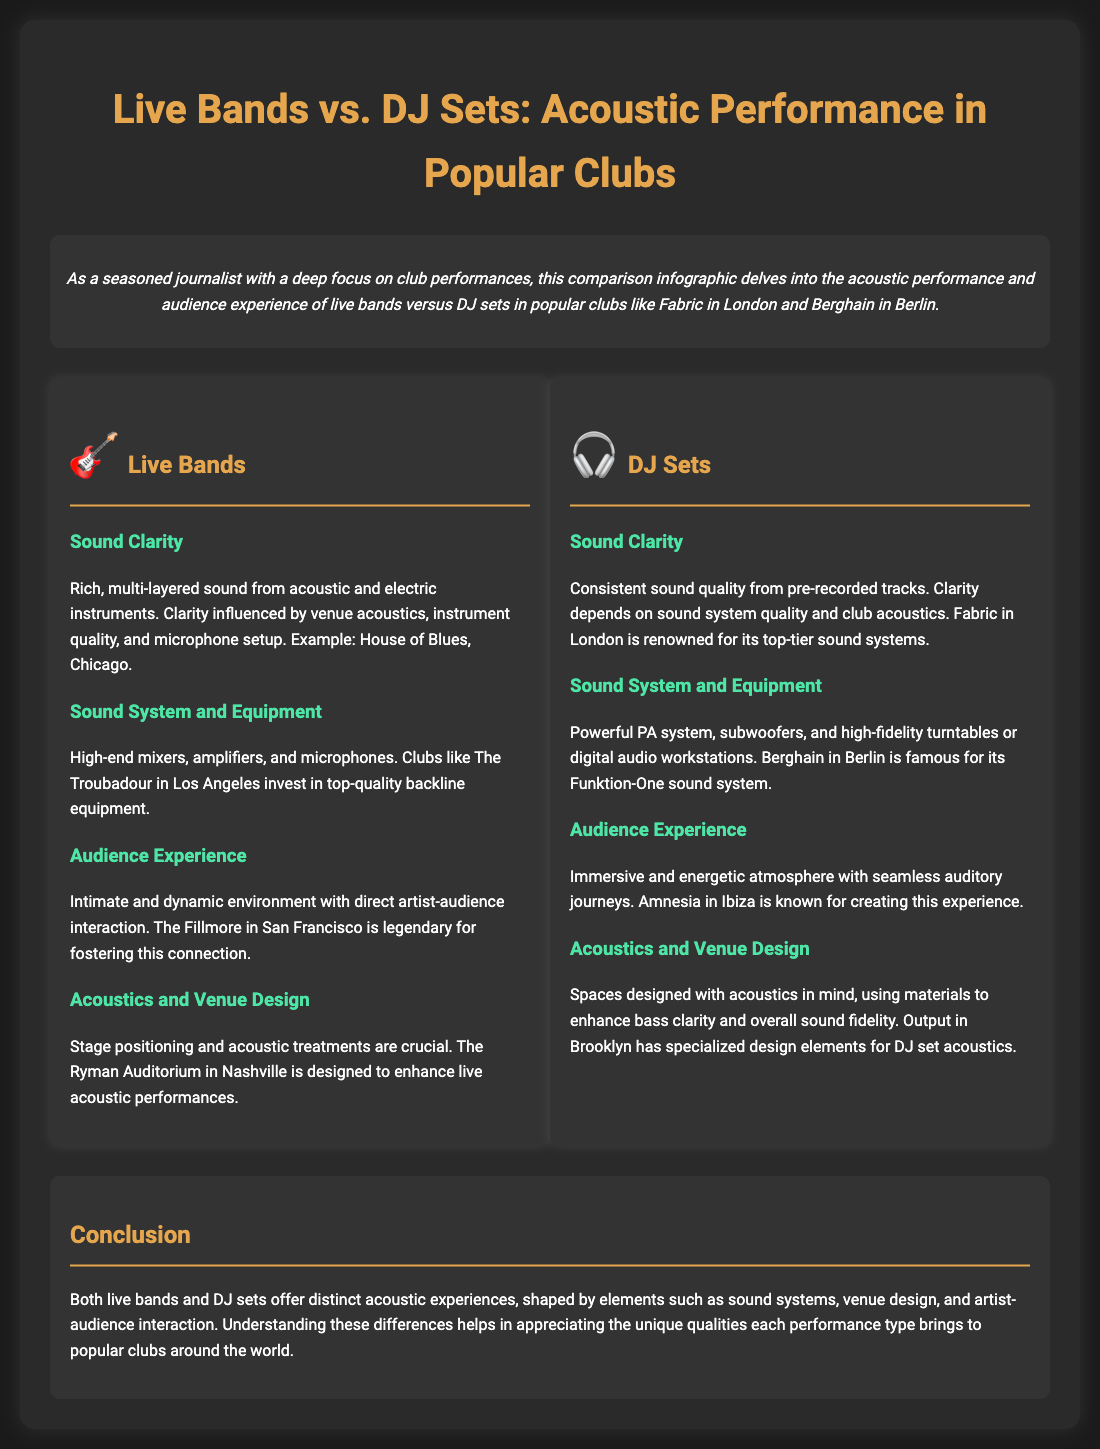what is one club known for live band performances? The document cites House of Blues in Chicago as an example of a venue for live band performances.
Answer: House of Blues, Chicago which club is famous for its Funktion-One sound system? Berghain in Berlin is highlighted for its renowned sound system in the document.
Answer: Berghain, Berlin what aspect influences sound clarity for live bands? The sound clarity for live bands is influenced by venue acoustics, instrument quality, and microphone setup.
Answer: Venue acoustics, instrument quality, microphone setup what is the audience experience like during DJ sets? The document describes the audience experience during DJ sets as immersive and energetic, with seamless auditory journeys.
Answer: Immersive and energetic which type of performance fosters direct artist-audience interaction? Live bands create an intimate environment that fosters direct artist-audience interaction, as stated in the document.
Answer: Live bands how does the document categorize the comparison? The document categorizes the comparison into sections for Live Bands and DJ Sets.
Answer: Live Bands and DJ Sets what is a key element for enhancing sound fidelity in DJ setups? The document mentions that spaces designed with acoustics in mind and using materials to enhance bass clarity are key elements for sound fidelity in DJ setups.
Answer: Acoustics and materials what city is associated with the club Fabric? Fabric is located in London, as referenced in the document.
Answer: London 